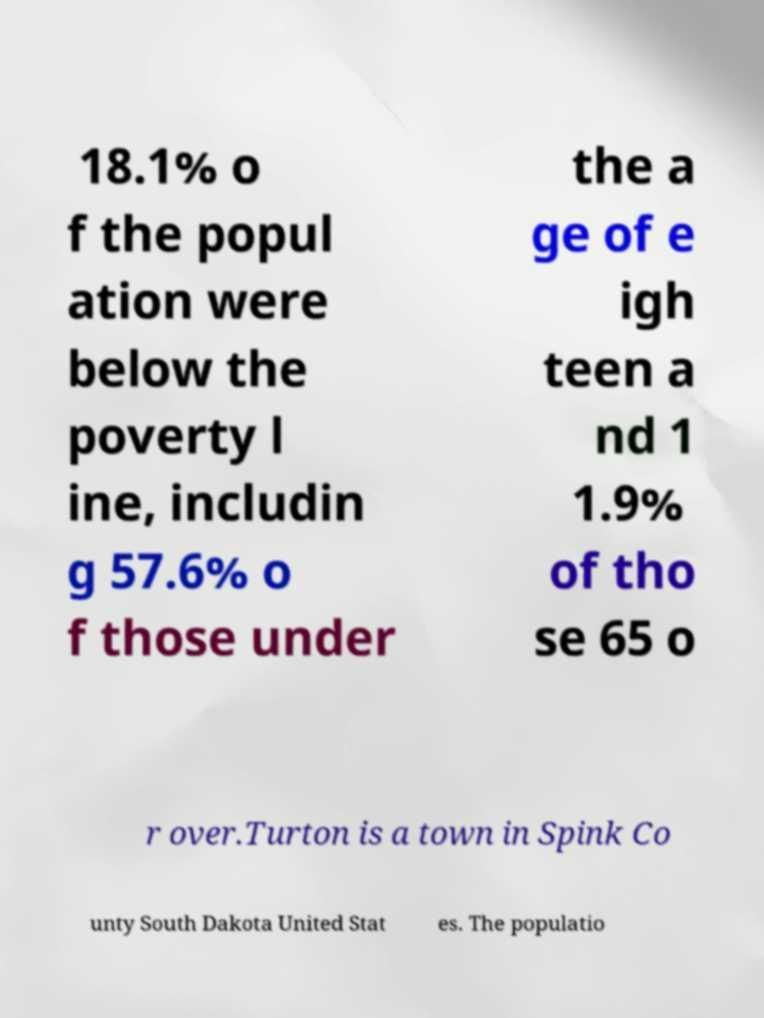Could you extract and type out the text from this image? 18.1% o f the popul ation were below the poverty l ine, includin g 57.6% o f those under the a ge of e igh teen a nd 1 1.9% of tho se 65 o r over.Turton is a town in Spink Co unty South Dakota United Stat es. The populatio 